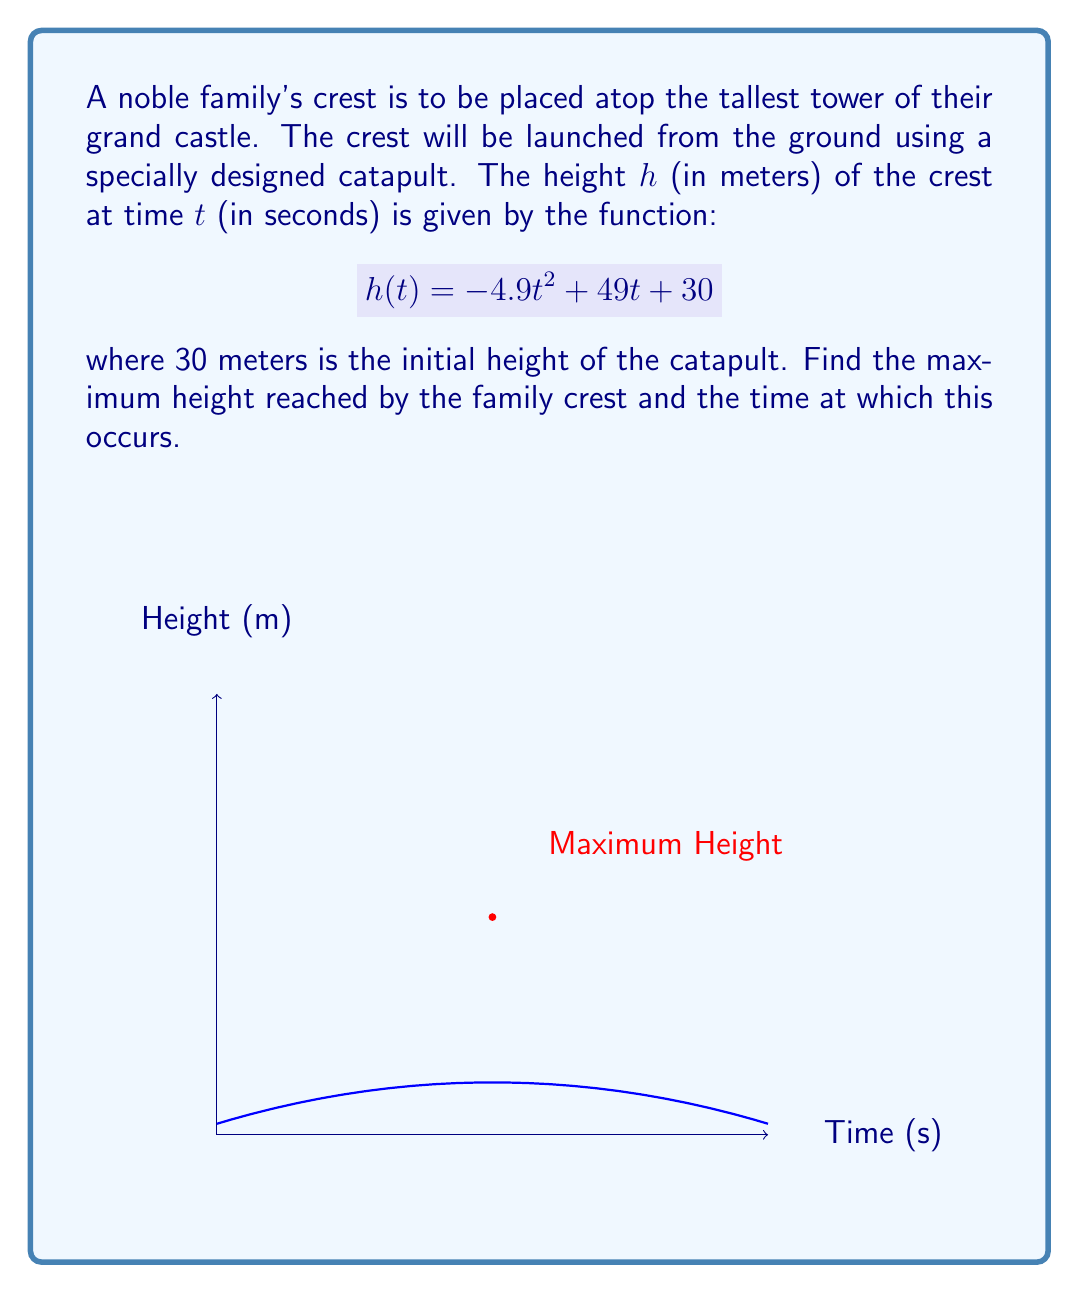Give your solution to this math problem. To find the maximum height, we need to find the vertex of the parabola described by $h(t)$. We can do this using the following steps:

1) The function $h(t) = -4.9t^2 + 49t + 30$ is a quadratic function in the form $f(x) = ax^2 + bx + c$, where:
   $a = -4.9$, $b = 49$, and $c = 30$

2) For a quadratic function, the $t$-coordinate of the vertex is given by $t = -\frac{b}{2a}$:

   $$t = -\frac{49}{2(-4.9)} = \frac{49}{9.8} = 5$$

3) To find the maximum height, we substitute this $t$ value back into the original function:

   $$\begin{align}
   h(5) &= -4.9(5)^2 + 49(5) + 30 \\
   &= -4.9(25) + 245 + 30 \\
   &= -122.5 + 245 + 30 \\
   &= 152.5
   \end{align}$$

Therefore, the maximum height reached by the family crest is 152.5 meters, and this occurs 5 seconds after launch.
Answer: Maximum height: 152.5 m; Time: 5 s 